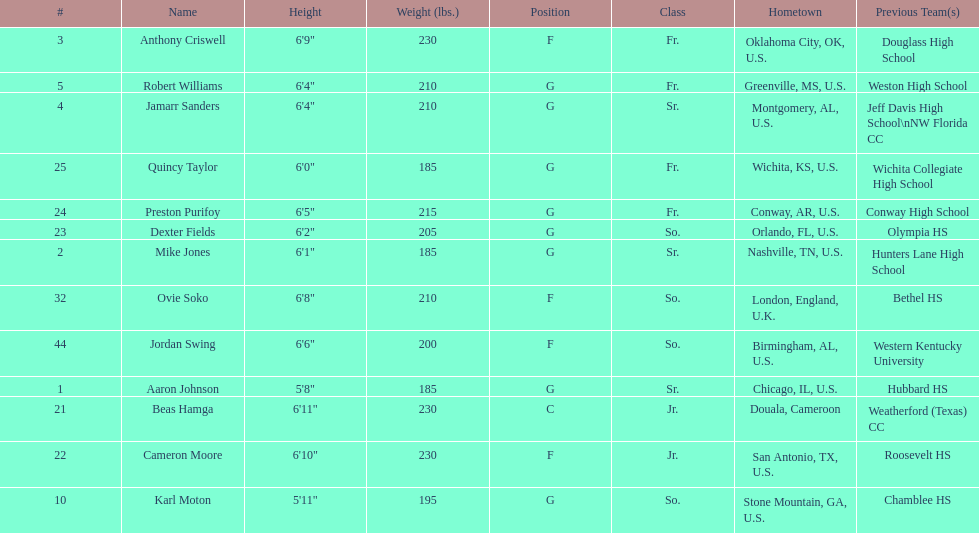What is the difference in weight between dexter fields and quincy taylor? 20. 